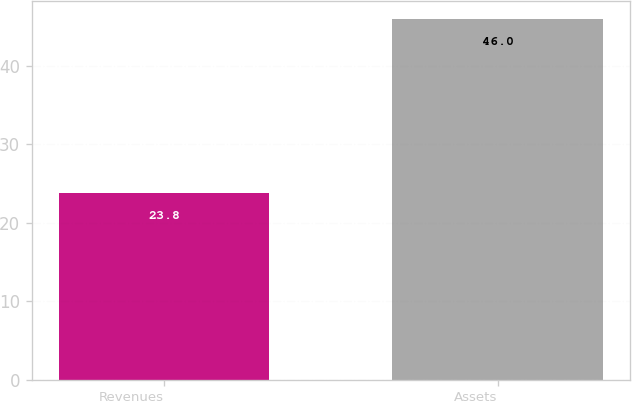Convert chart. <chart><loc_0><loc_0><loc_500><loc_500><bar_chart><fcel>Revenues<fcel>Assets<nl><fcel>23.8<fcel>46<nl></chart> 